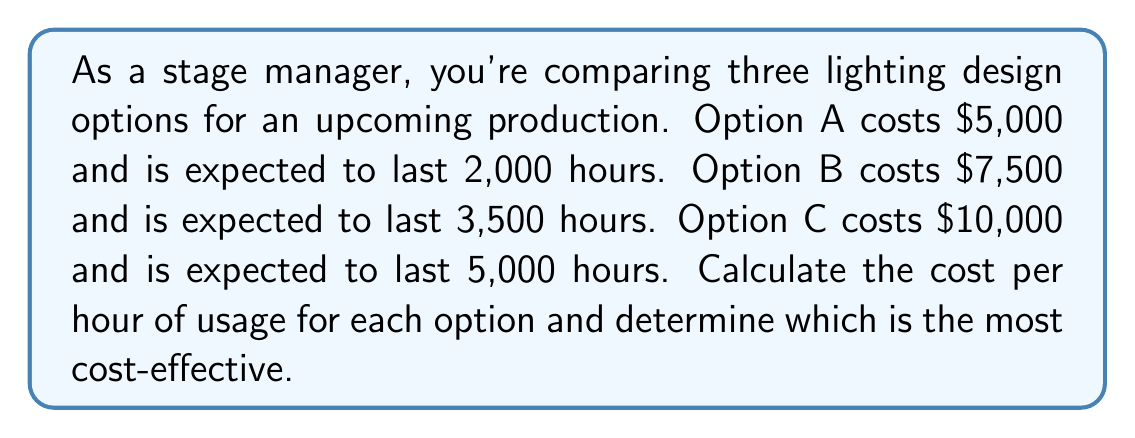Can you solve this math problem? To determine the cost-effectiveness of each lighting design option, we need to calculate the cost per hour of usage for each option. This can be done by dividing the total cost by the expected hours of usage.

1. For Option A:
   Cost per hour = $\frac{\text{Total cost}}{\text{Expected hours of usage}}$
   $$ \text{Cost per hour}_A = \frac{\$5,000}{2,000 \text{ hours}} = \$2.50 \text{ per hour} $$

2. For Option B:
   $$ \text{Cost per hour}_B = \frac{\$7,500}{3,500 \text{ hours}} = \$2.14 \text{ per hour} $$

3. For Option C:
   $$ \text{Cost per hour}_C = \frac{\$10,000}{5,000 \text{ hours}} = \$2.00 \text{ per hour} $$

Comparing the results:
Option A: $2.50 per hour
Option B: $2.14 per hour
Option C: $2.00 per hour

Option C has the lowest cost per hour, making it the most cost-effective choice among the three options.
Answer: Option C at $2.00 per hour 